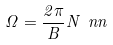<formula> <loc_0><loc_0><loc_500><loc_500>\Omega = \frac { 2 \pi } { B } N \ n n</formula> 